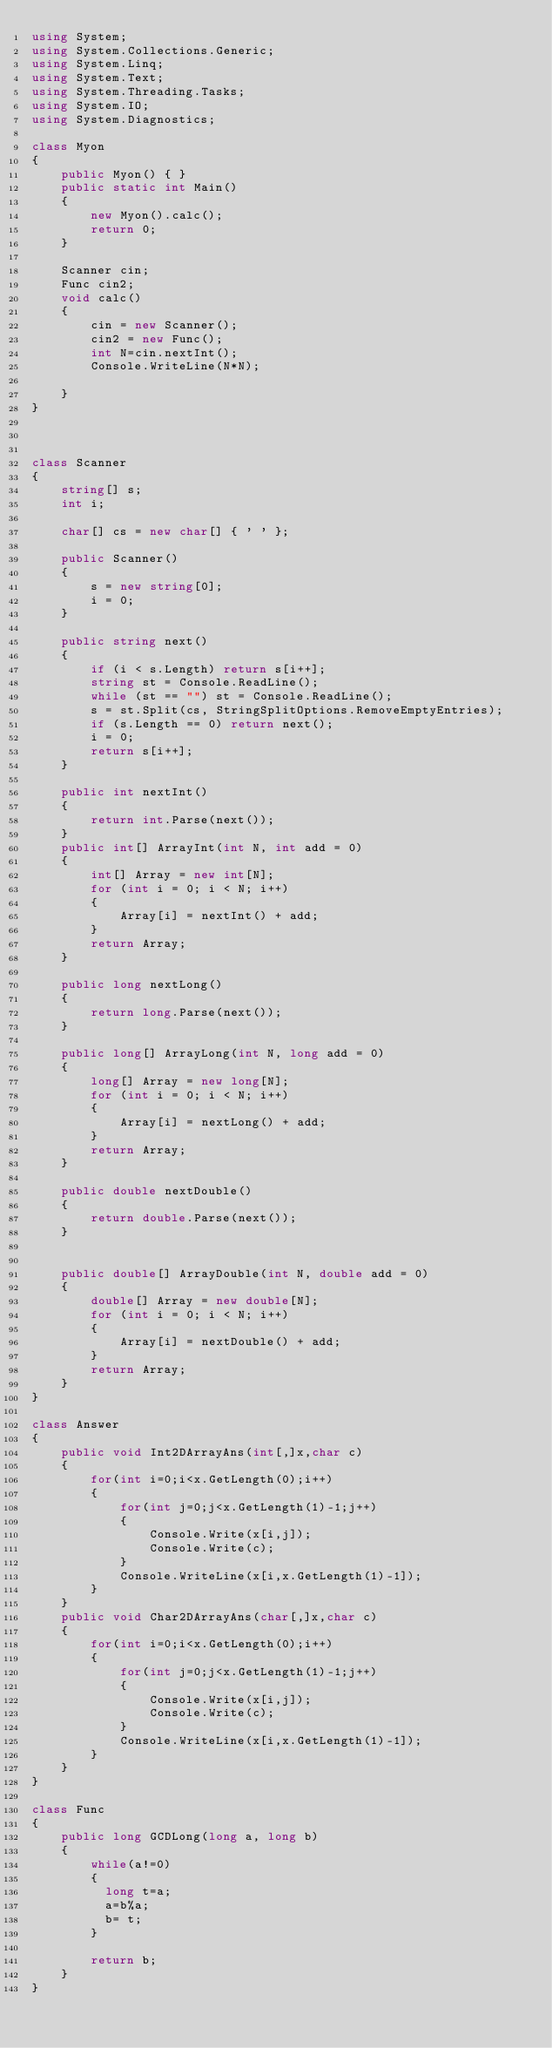Convert code to text. <code><loc_0><loc_0><loc_500><loc_500><_C#_>using System;
using System.Collections.Generic;
using System.Linq;
using System.Text;
using System.Threading.Tasks;
using System.IO;
using System.Diagnostics;

class Myon
{
    public Myon() { }
    public static int Main()
    {
        new Myon().calc();
        return 0;
    }

    Scanner cin;
    Func cin2;
    void calc()
    {
        cin = new Scanner();
        cin2 = new Func();
        int N=cin.nextInt();
        Console.WriteLine(N*N);

    }
}



class Scanner
{
    string[] s;
    int i;

    char[] cs = new char[] { ' ' };

    public Scanner()
    {
        s = new string[0];
        i = 0;
    }

    public string next()
    {
        if (i < s.Length) return s[i++];
        string st = Console.ReadLine();
        while (st == "") st = Console.ReadLine();
        s = st.Split(cs, StringSplitOptions.RemoveEmptyEntries);
        if (s.Length == 0) return next();
        i = 0;
        return s[i++];
    }

    public int nextInt()
    {
        return int.Parse(next());
    }
    public int[] ArrayInt(int N, int add = 0)
    {
        int[] Array = new int[N];
        for (int i = 0; i < N; i++)
        {
            Array[i] = nextInt() + add;
        }
        return Array;
    }

    public long nextLong()
    {
        return long.Parse(next());
    }

    public long[] ArrayLong(int N, long add = 0)
    {
        long[] Array = new long[N];
        for (int i = 0; i < N; i++)
        {
            Array[i] = nextLong() + add;
        }
        return Array;
    }

    public double nextDouble()
    {
        return double.Parse(next());
    }


    public double[] ArrayDouble(int N, double add = 0)
    {
        double[] Array = new double[N];
        for (int i = 0; i < N; i++)
        {
            Array[i] = nextDouble() + add;
        }
        return Array;
    }
}

class Answer
{
    public void Int2DArrayAns(int[,]x,char c)
    {
        for(int i=0;i<x.GetLength(0);i++)
        {
            for(int j=0;j<x.GetLength(1)-1;j++)
            {
                Console.Write(x[i,j]);
                Console.Write(c);
            }
            Console.WriteLine(x[i,x.GetLength(1)-1]);
        }
    }
    public void Char2DArrayAns(char[,]x,char c)
    {
        for(int i=0;i<x.GetLength(0);i++)
        {
            for(int j=0;j<x.GetLength(1)-1;j++)
            {
                Console.Write(x[i,j]);
                Console.Write(c);
            }
            Console.WriteLine(x[i,x.GetLength(1)-1]);
        }
    }
}

class Func
{
    public long GCDLong(long a, long b)
    {
        while(a!=0)
        {
          long t=a;
          a=b%a;
          b= t;
        }
      
        return b;        
    }
}</code> 